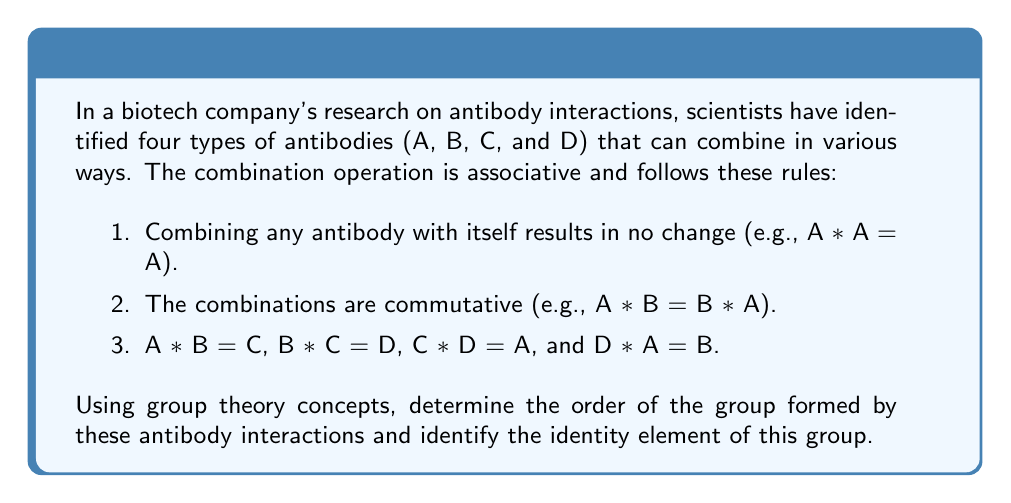What is the answer to this math problem? To solve this problem, we'll use the properties of groups in abstract algebra:

1. First, let's create a Cayley table to visualize all possible combinations:

   $$\begin{array}{c|cccc}
   * & A & B & C & D \\
   \hline
   A & A & C & D & B \\
   B & C & B & D & A \\
   C & D & D & C & A \\
   D & B & A & A & D
   \end{array}$$

2. To determine if this forms a group, we need to check the group axioms:

   a) Closure: All combinations result in elements within the set {A, B, C, D}.
   b) Associativity: Given by the problem statement.
   c) Identity element: We need to find an element that, when combined with any other element, leaves it unchanged.
   d) Inverse elements: For each element, there should be another element that, when combined, results in the identity element.

3. From the Cayley table, we can see that A serves as the identity element because:
   A * A = A, A * B = B, A * C = C, and A * D = D

4. We can also verify that each element has an inverse:
   A * A = A (A is its own inverse)
   B * B = B (B is its own inverse)
   C * C = C (C is its own inverse)
   D * D = D (D is its own inverse)

5. Since all group axioms are satisfied, this indeed forms a group.

6. The order of a group is the number of elements in the group. In this case, there are 4 elements: A, B, C, and D.

Therefore, the order of the group is 4, and the identity element is A.
Answer: The order of the group is 4, and the identity element is A. 